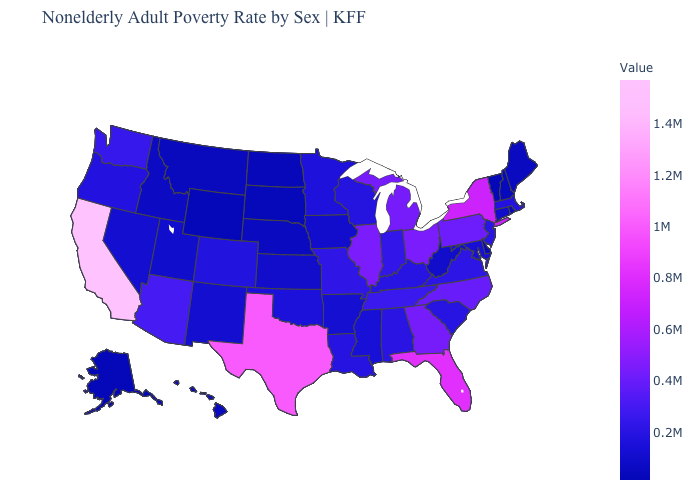Among the states that border Wisconsin , does Illinois have the highest value?
Be succinct. Yes. Which states have the highest value in the USA?
Short answer required. California. Among the states that border Michigan , does Wisconsin have the lowest value?
Write a very short answer. Yes. Does Rhode Island have the highest value in the Northeast?
Answer briefly. No. 